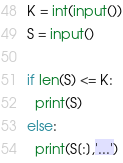<code> <loc_0><loc_0><loc_500><loc_500><_Python_>K = int(input())
S = input()

if len(S) <= K:
  print(S)
else:
  print(S[:],'...')</code> 